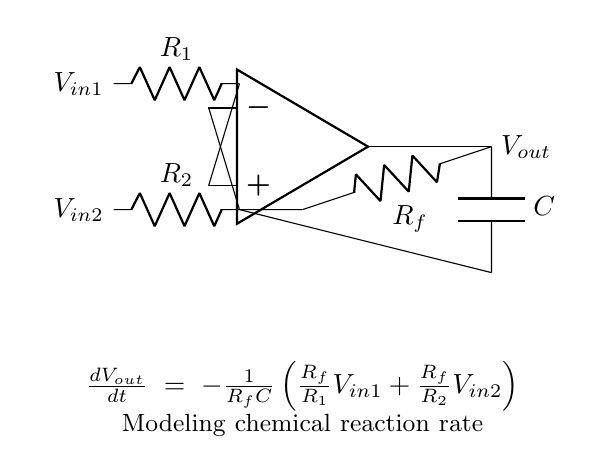What type of amplifier is this circuit? The circuit is an operational amplifier configuration, commonly used for various signal processing tasks including modeling chemical reactions.
Answer: operational amplifier What is the role of the capacitor in the circuit? The capacitor is connected in the feedback loop, which affects the rate of change of the output voltage, contributing to the timing characteristics and dynamic behavior of the circuit.
Answer: timing characteristics What are the input voltages in this circuit? The input voltages, represented as \( V_{in1} \) and \( V_{in2} \), are connected to the non-inverting and inverting terminals of the operational amplifier respectively.
Answer: V in1 and V in2 What is the equation provided in the circuit for the output voltage? The equation \(\frac{dV_{out}}{dt} = -\frac{1}{R_fC}\left(\frac{R_f}{R_1}V_{in1} + \frac{R_f}{R_2}V_{in2}\right)\) describes the relationship between the output voltage change rate, input voltages, and circuit components.
Answer: differential equation for output voltage How does changing \( R_1 \) affect \( V_{out} \)? Increasing \( R_1 \) decreases the influence of \( V_{in1} \) on the output, causing a slower change rate of \( V_{out} \) according to the equation provided.
Answer: slower change rate What is the feedback resistor in this circuit? The feedback resistor is labeled \( R_f \), and it is crucial for determining the gain and dynamic response of the operational amplifier.
Answer: R f What does the circuit imply about reaction rates? The circuit models chemical reaction rates by representing changes in output voltage as a function of input voltages, demonstrating how the components interact to simulate dynamic systems such as chemical processes.
Answer: models chemical reaction rates 